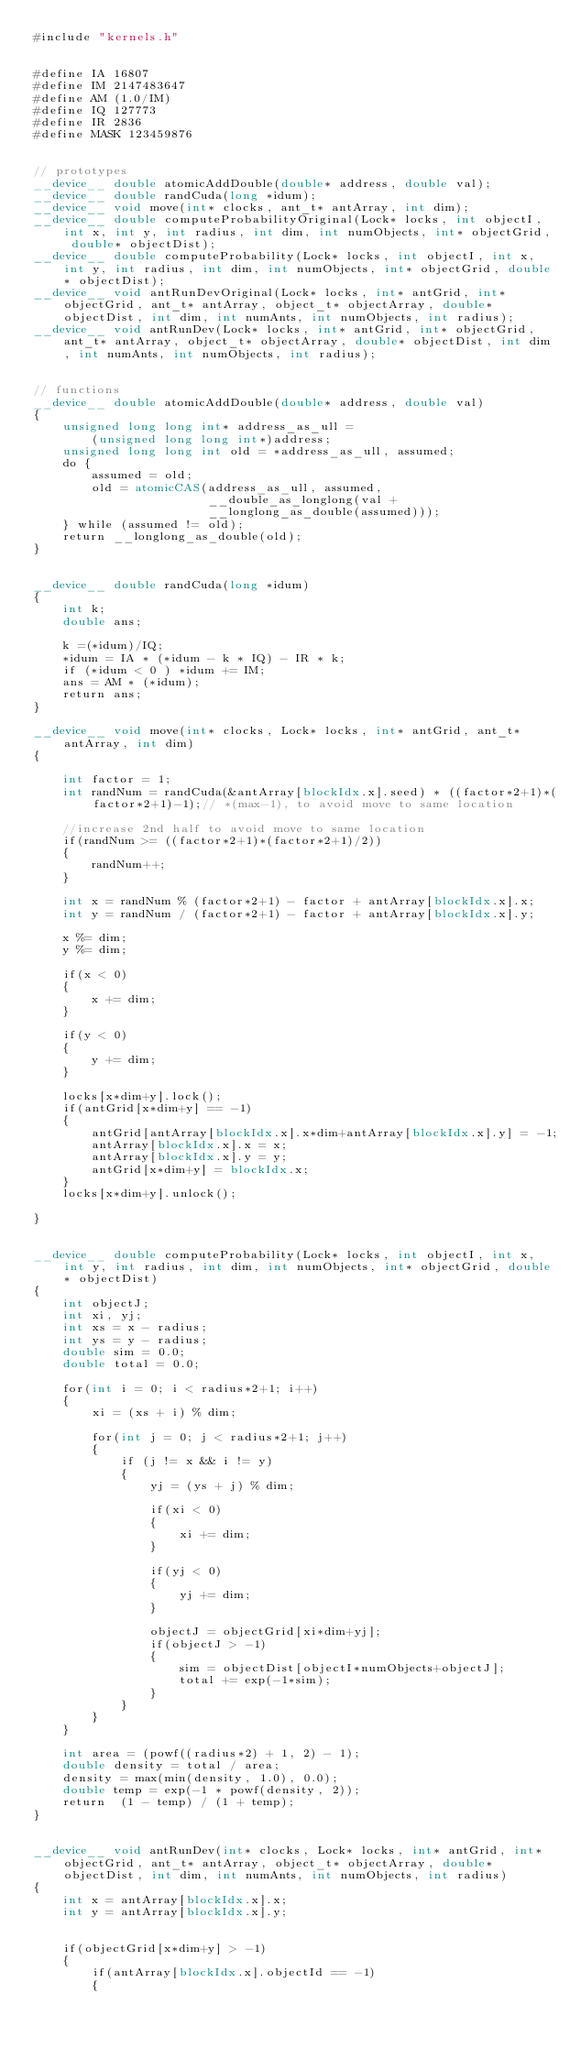Convert code to text. <code><loc_0><loc_0><loc_500><loc_500><_Cuda_>#include "kernels.h"


#define IA 16807
#define IM 2147483647
#define AM (1.0/IM)
#define IQ 127773
#define IR 2836
#define MASK 123459876


// prototypes
__device__ double atomicAddDouble(double* address, double val);
__device__ double randCuda(long *idum);
__device__ void move(int* clocks, ant_t* antArray, int dim);
__device__ double computeProbabilityOriginal(Lock* locks, int objectI, int x, int y, int radius, int dim, int numObjects, int* objectGrid, double* objectDist);
__device__ double computeProbability(Lock* locks, int objectI, int x, int y, int radius, int dim, int numObjects, int* objectGrid, double* objectDist);
__device__ void antRunDevOriginal(Lock* locks, int* antGrid, int* objectGrid, ant_t* antArray, object_t* objectArray, double* objectDist, int dim, int numAnts, int numObjects, int radius);
__device__ void antRunDev(Lock* locks, int* antGrid, int* objectGrid, ant_t* antArray, object_t* objectArray, double* objectDist, int dim, int numAnts, int numObjects, int radius);


// functions
__device__ double atomicAddDouble(double* address, double val)
{
	unsigned long long int* address_as_ull = 
	    (unsigned long long int*)address;
    unsigned long long int old = *address_as_ull, assumed;
    do {
        assumed = old;
        old = atomicCAS(address_as_ull, assumed, 
                        __double_as_longlong(val + 
                        __longlong_as_double(assumed)));
    } while (assumed != old);
    return __longlong_as_double(old);
}


__device__ double randCuda(long *idum)
{
	int k;
	double ans;

	k =(*idum)/IQ;
	*idum = IA * (*idum - k * IQ) - IR * k;
	if (*idum < 0 ) *idum += IM;
	ans = AM * (*idum);
	return ans;
}

__device__ void move(int* clocks, Lock* locks, int* antGrid, ant_t* antArray, int dim)
{
	
	int factor = 1;
	int randNum = randCuda(&antArray[blockIdx.x].seed) * ((factor*2+1)*(factor*2+1)-1);// *(max-1), to avoid move to same location

	//increase 2nd half to avoid move to same location
	if(randNum >= ((factor*2+1)*(factor*2+1)/2))
	{
		randNum++;
	}

	int x = randNum % (factor*2+1) - factor + antArray[blockIdx.x].x;
	int y = randNum / (factor*2+1) - factor + antArray[blockIdx.x].y;

	x %= dim;
	y %= dim;

	if(x < 0)
	{
		x += dim;
	}
	
	if(y < 0)
	{
		y += dim;
	}	
		
	locks[x*dim+y].lock();
	if(antGrid[x*dim+y] == -1)
	{
		antGrid[antArray[blockIdx.x].x*dim+antArray[blockIdx.x].y] = -1;
		antArray[blockIdx.x].x = x;
		antArray[blockIdx.x].y = y;
		antGrid[x*dim+y] = blockIdx.x;
	}
	locks[x*dim+y].unlock();

}


__device__ double computeProbability(Lock* locks, int objectI, int x, int y, int radius, int dim, int numObjects, int* objectGrid, double* objectDist)
{
	int objectJ;
	int xi, yj;
	int xs = x - radius;
	int ys = y - radius;
	double sim = 0.0;
	double total = 0.0;

	for(int i = 0; i < radius*2+1; i++)
	{
		xi = (xs + i) % dim;

		for(int j = 0; j < radius*2+1; j++)
		{
			if (j != x && i != y)
			{
				yj = (ys + j) % dim;

				if(xi < 0)
				{
					xi += dim;
				}

				if(yj < 0)
				{
					yj += dim;
				}

				objectJ = objectGrid[xi*dim+yj];
				if(objectJ > -1)
				{
					sim = objectDist[objectI*numObjects+objectJ];
					total += exp(-1*sim);
				}
			}
		}
	}

	int area = (powf((radius*2) + 1, 2) - 1);
	double density = total / area;
	density = max(min(density, 1.0), 0.0);
	double temp = exp(-1 * powf(density, 2));
	return  (1 - temp) / (1 + temp);
}


__device__ void antRunDev(int* clocks, Lock* locks, int* antGrid, int* objectGrid, ant_t* antArray, object_t* objectArray, double* objectDist, int dim, int numAnts, int numObjects, int radius)
{
	int x = antArray[blockIdx.x].x;
	int y = antArray[blockIdx.x].y;
  

	if(objectGrid[x*dim+y] > -1)
	{
		if(antArray[blockIdx.x].objectId == -1)
		{</code> 